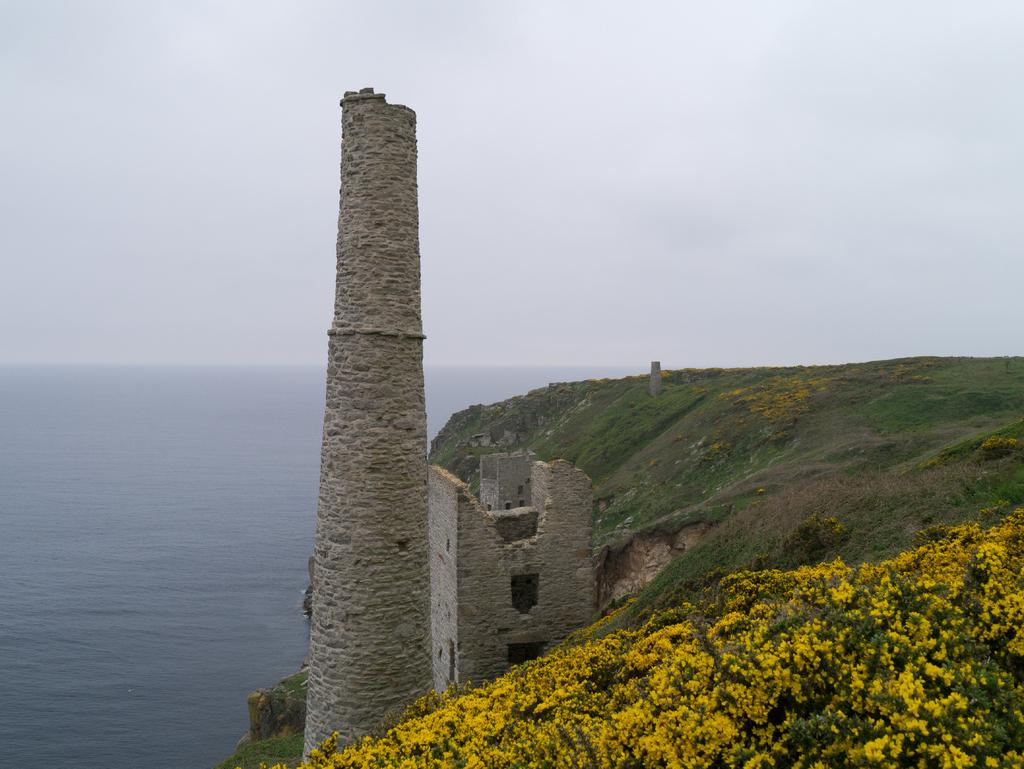What is the main structure in the image? There is a tower in the image. What color is the grass in the background? The grass in the background is green. What color are the flowers in the background? The flowers in the background are yellow. What color is the sky in the background? The sky in the background is white. How does the tower express its feelings of hate towards the flowers in the image? The tower is an inanimate object and does not have feelings or the ability to express emotions like hate. 